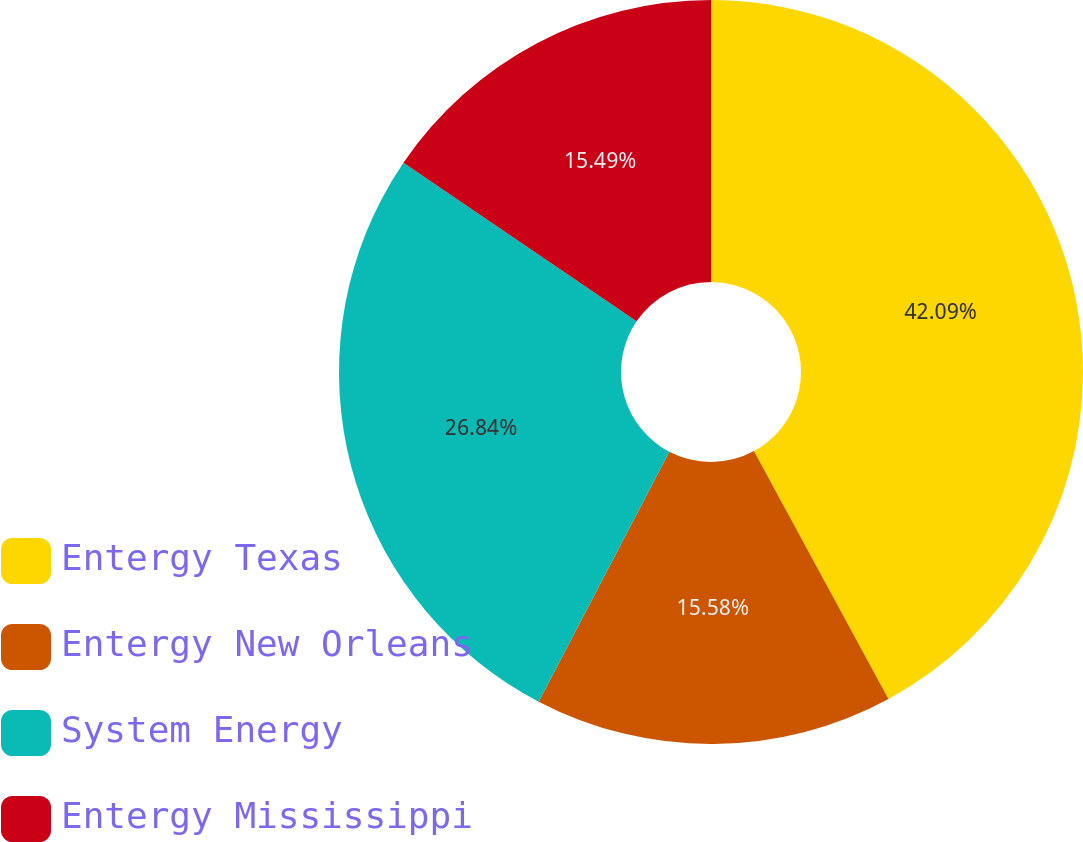<chart> <loc_0><loc_0><loc_500><loc_500><pie_chart><fcel>Entergy Texas<fcel>Entergy New Orleans<fcel>System Energy<fcel>Entergy Mississippi<nl><fcel>42.08%<fcel>15.58%<fcel>26.84%<fcel>15.49%<nl></chart> 